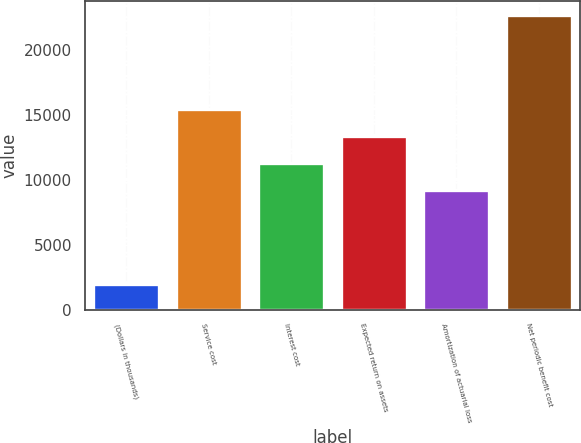<chart> <loc_0><loc_0><loc_500><loc_500><bar_chart><fcel>(Dollars in thousands)<fcel>Service cost<fcel>Interest cost<fcel>Expected return on assets<fcel>Amortization of actuarial loss<fcel>Net periodic benefit cost<nl><fcel>2015<fcel>15443.1<fcel>11309.7<fcel>13376.4<fcel>9243<fcel>22682<nl></chart> 